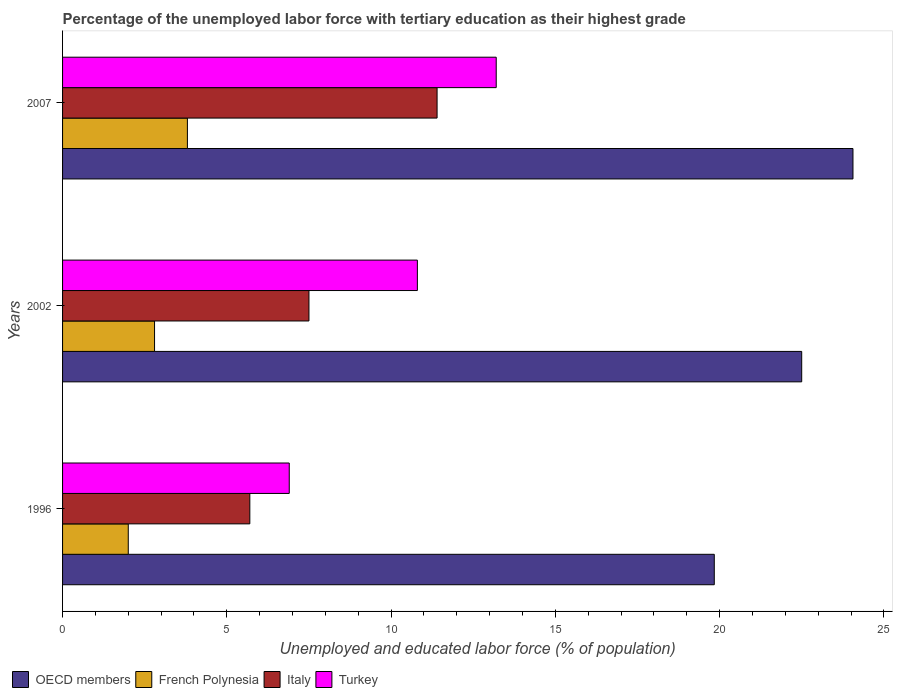How many different coloured bars are there?
Your response must be concise. 4. Are the number of bars per tick equal to the number of legend labels?
Offer a terse response. Yes. Are the number of bars on each tick of the Y-axis equal?
Ensure brevity in your answer.  Yes. How many bars are there on the 3rd tick from the top?
Ensure brevity in your answer.  4. What is the label of the 1st group of bars from the top?
Provide a succinct answer. 2007. In how many cases, is the number of bars for a given year not equal to the number of legend labels?
Offer a terse response. 0. What is the percentage of the unemployed labor force with tertiary education in Turkey in 2002?
Offer a terse response. 10.8. Across all years, what is the maximum percentage of the unemployed labor force with tertiary education in Turkey?
Your response must be concise. 13.2. Across all years, what is the minimum percentage of the unemployed labor force with tertiary education in Turkey?
Your answer should be compact. 6.9. What is the total percentage of the unemployed labor force with tertiary education in OECD members in the graph?
Provide a short and direct response. 66.4. What is the difference between the percentage of the unemployed labor force with tertiary education in Italy in 1996 and that in 2007?
Ensure brevity in your answer.  -5.7. What is the difference between the percentage of the unemployed labor force with tertiary education in Turkey in 1996 and the percentage of the unemployed labor force with tertiary education in French Polynesia in 2007?
Provide a succinct answer. 3.1. What is the average percentage of the unemployed labor force with tertiary education in Turkey per year?
Make the answer very short. 10.3. In the year 1996, what is the difference between the percentage of the unemployed labor force with tertiary education in Turkey and percentage of the unemployed labor force with tertiary education in OECD members?
Provide a short and direct response. -12.94. What is the ratio of the percentage of the unemployed labor force with tertiary education in Italy in 1996 to that in 2007?
Make the answer very short. 0.5. What is the difference between the highest and the second highest percentage of the unemployed labor force with tertiary education in Turkey?
Your answer should be very brief. 2.4. What is the difference between the highest and the lowest percentage of the unemployed labor force with tertiary education in French Polynesia?
Provide a short and direct response. 1.8. Is it the case that in every year, the sum of the percentage of the unemployed labor force with tertiary education in Turkey and percentage of the unemployed labor force with tertiary education in French Polynesia is greater than the sum of percentage of the unemployed labor force with tertiary education in OECD members and percentage of the unemployed labor force with tertiary education in Italy?
Give a very brief answer. No. What does the 3rd bar from the top in 1996 represents?
Your answer should be very brief. French Polynesia. What does the 1st bar from the bottom in 1996 represents?
Give a very brief answer. OECD members. How many bars are there?
Provide a short and direct response. 12. What is the difference between two consecutive major ticks on the X-axis?
Offer a very short reply. 5. Are the values on the major ticks of X-axis written in scientific E-notation?
Ensure brevity in your answer.  No. How are the legend labels stacked?
Offer a very short reply. Horizontal. What is the title of the graph?
Ensure brevity in your answer.  Percentage of the unemployed labor force with tertiary education as their highest grade. Does "Cameroon" appear as one of the legend labels in the graph?
Keep it short and to the point. No. What is the label or title of the X-axis?
Give a very brief answer. Unemployed and educated labor force (% of population). What is the Unemployed and educated labor force (% of population) in OECD members in 1996?
Your answer should be very brief. 19.84. What is the Unemployed and educated labor force (% of population) in French Polynesia in 1996?
Your answer should be very brief. 2. What is the Unemployed and educated labor force (% of population) in Italy in 1996?
Provide a succinct answer. 5.7. What is the Unemployed and educated labor force (% of population) of Turkey in 1996?
Keep it short and to the point. 6.9. What is the Unemployed and educated labor force (% of population) of OECD members in 2002?
Offer a terse response. 22.5. What is the Unemployed and educated labor force (% of population) of French Polynesia in 2002?
Give a very brief answer. 2.8. What is the Unemployed and educated labor force (% of population) in Italy in 2002?
Ensure brevity in your answer.  7.5. What is the Unemployed and educated labor force (% of population) of Turkey in 2002?
Your answer should be compact. 10.8. What is the Unemployed and educated labor force (% of population) of OECD members in 2007?
Offer a terse response. 24.06. What is the Unemployed and educated labor force (% of population) in French Polynesia in 2007?
Your answer should be compact. 3.8. What is the Unemployed and educated labor force (% of population) of Italy in 2007?
Offer a terse response. 11.4. What is the Unemployed and educated labor force (% of population) of Turkey in 2007?
Your answer should be very brief. 13.2. Across all years, what is the maximum Unemployed and educated labor force (% of population) of OECD members?
Provide a short and direct response. 24.06. Across all years, what is the maximum Unemployed and educated labor force (% of population) of French Polynesia?
Provide a short and direct response. 3.8. Across all years, what is the maximum Unemployed and educated labor force (% of population) of Italy?
Your answer should be compact. 11.4. Across all years, what is the maximum Unemployed and educated labor force (% of population) in Turkey?
Provide a short and direct response. 13.2. Across all years, what is the minimum Unemployed and educated labor force (% of population) in OECD members?
Your answer should be very brief. 19.84. Across all years, what is the minimum Unemployed and educated labor force (% of population) in Italy?
Your answer should be compact. 5.7. Across all years, what is the minimum Unemployed and educated labor force (% of population) of Turkey?
Keep it short and to the point. 6.9. What is the total Unemployed and educated labor force (% of population) in OECD members in the graph?
Make the answer very short. 66.4. What is the total Unemployed and educated labor force (% of population) of Italy in the graph?
Your answer should be very brief. 24.6. What is the total Unemployed and educated labor force (% of population) in Turkey in the graph?
Offer a very short reply. 30.9. What is the difference between the Unemployed and educated labor force (% of population) of OECD members in 1996 and that in 2002?
Your response must be concise. -2.66. What is the difference between the Unemployed and educated labor force (% of population) of French Polynesia in 1996 and that in 2002?
Offer a very short reply. -0.8. What is the difference between the Unemployed and educated labor force (% of population) of Italy in 1996 and that in 2002?
Your answer should be very brief. -1.8. What is the difference between the Unemployed and educated labor force (% of population) of OECD members in 1996 and that in 2007?
Offer a terse response. -4.22. What is the difference between the Unemployed and educated labor force (% of population) in Italy in 1996 and that in 2007?
Provide a succinct answer. -5.7. What is the difference between the Unemployed and educated labor force (% of population) of OECD members in 2002 and that in 2007?
Your answer should be very brief. -1.56. What is the difference between the Unemployed and educated labor force (% of population) in French Polynesia in 2002 and that in 2007?
Your answer should be compact. -1. What is the difference between the Unemployed and educated labor force (% of population) in OECD members in 1996 and the Unemployed and educated labor force (% of population) in French Polynesia in 2002?
Offer a terse response. 17.04. What is the difference between the Unemployed and educated labor force (% of population) of OECD members in 1996 and the Unemployed and educated labor force (% of population) of Italy in 2002?
Keep it short and to the point. 12.34. What is the difference between the Unemployed and educated labor force (% of population) of OECD members in 1996 and the Unemployed and educated labor force (% of population) of Turkey in 2002?
Offer a very short reply. 9.04. What is the difference between the Unemployed and educated labor force (% of population) of French Polynesia in 1996 and the Unemployed and educated labor force (% of population) of Turkey in 2002?
Make the answer very short. -8.8. What is the difference between the Unemployed and educated labor force (% of population) in OECD members in 1996 and the Unemployed and educated labor force (% of population) in French Polynesia in 2007?
Provide a succinct answer. 16.04. What is the difference between the Unemployed and educated labor force (% of population) of OECD members in 1996 and the Unemployed and educated labor force (% of population) of Italy in 2007?
Offer a very short reply. 8.44. What is the difference between the Unemployed and educated labor force (% of population) in OECD members in 1996 and the Unemployed and educated labor force (% of population) in Turkey in 2007?
Offer a very short reply. 6.64. What is the difference between the Unemployed and educated labor force (% of population) of French Polynesia in 1996 and the Unemployed and educated labor force (% of population) of Italy in 2007?
Your answer should be compact. -9.4. What is the difference between the Unemployed and educated labor force (% of population) of OECD members in 2002 and the Unemployed and educated labor force (% of population) of French Polynesia in 2007?
Offer a terse response. 18.7. What is the difference between the Unemployed and educated labor force (% of population) of OECD members in 2002 and the Unemployed and educated labor force (% of population) of Italy in 2007?
Provide a succinct answer. 11.1. What is the difference between the Unemployed and educated labor force (% of population) in OECD members in 2002 and the Unemployed and educated labor force (% of population) in Turkey in 2007?
Ensure brevity in your answer.  9.3. What is the difference between the Unemployed and educated labor force (% of population) of French Polynesia in 2002 and the Unemployed and educated labor force (% of population) of Italy in 2007?
Provide a succinct answer. -8.6. What is the difference between the Unemployed and educated labor force (% of population) in French Polynesia in 2002 and the Unemployed and educated labor force (% of population) in Turkey in 2007?
Your answer should be very brief. -10.4. What is the difference between the Unemployed and educated labor force (% of population) in Italy in 2002 and the Unemployed and educated labor force (% of population) in Turkey in 2007?
Offer a very short reply. -5.7. What is the average Unemployed and educated labor force (% of population) in OECD members per year?
Your answer should be compact. 22.13. What is the average Unemployed and educated labor force (% of population) in French Polynesia per year?
Provide a short and direct response. 2.87. What is the average Unemployed and educated labor force (% of population) of Italy per year?
Provide a succinct answer. 8.2. What is the average Unemployed and educated labor force (% of population) of Turkey per year?
Your response must be concise. 10.3. In the year 1996, what is the difference between the Unemployed and educated labor force (% of population) in OECD members and Unemployed and educated labor force (% of population) in French Polynesia?
Ensure brevity in your answer.  17.84. In the year 1996, what is the difference between the Unemployed and educated labor force (% of population) in OECD members and Unemployed and educated labor force (% of population) in Italy?
Your answer should be compact. 14.14. In the year 1996, what is the difference between the Unemployed and educated labor force (% of population) of OECD members and Unemployed and educated labor force (% of population) of Turkey?
Keep it short and to the point. 12.94. In the year 1996, what is the difference between the Unemployed and educated labor force (% of population) in French Polynesia and Unemployed and educated labor force (% of population) in Italy?
Offer a very short reply. -3.7. In the year 2002, what is the difference between the Unemployed and educated labor force (% of population) in OECD members and Unemployed and educated labor force (% of population) in French Polynesia?
Give a very brief answer. 19.7. In the year 2002, what is the difference between the Unemployed and educated labor force (% of population) of OECD members and Unemployed and educated labor force (% of population) of Italy?
Provide a short and direct response. 15. In the year 2002, what is the difference between the Unemployed and educated labor force (% of population) in OECD members and Unemployed and educated labor force (% of population) in Turkey?
Offer a very short reply. 11.7. In the year 2002, what is the difference between the Unemployed and educated labor force (% of population) of Italy and Unemployed and educated labor force (% of population) of Turkey?
Offer a terse response. -3.3. In the year 2007, what is the difference between the Unemployed and educated labor force (% of population) in OECD members and Unemployed and educated labor force (% of population) in French Polynesia?
Offer a terse response. 20.26. In the year 2007, what is the difference between the Unemployed and educated labor force (% of population) in OECD members and Unemployed and educated labor force (% of population) in Italy?
Make the answer very short. 12.66. In the year 2007, what is the difference between the Unemployed and educated labor force (% of population) in OECD members and Unemployed and educated labor force (% of population) in Turkey?
Your answer should be very brief. 10.86. In the year 2007, what is the difference between the Unemployed and educated labor force (% of population) in French Polynesia and Unemployed and educated labor force (% of population) in Italy?
Keep it short and to the point. -7.6. In the year 2007, what is the difference between the Unemployed and educated labor force (% of population) in French Polynesia and Unemployed and educated labor force (% of population) in Turkey?
Your response must be concise. -9.4. What is the ratio of the Unemployed and educated labor force (% of population) of OECD members in 1996 to that in 2002?
Provide a succinct answer. 0.88. What is the ratio of the Unemployed and educated labor force (% of population) of French Polynesia in 1996 to that in 2002?
Keep it short and to the point. 0.71. What is the ratio of the Unemployed and educated labor force (% of population) of Italy in 1996 to that in 2002?
Your response must be concise. 0.76. What is the ratio of the Unemployed and educated labor force (% of population) in Turkey in 1996 to that in 2002?
Your response must be concise. 0.64. What is the ratio of the Unemployed and educated labor force (% of population) of OECD members in 1996 to that in 2007?
Keep it short and to the point. 0.82. What is the ratio of the Unemployed and educated labor force (% of population) of French Polynesia in 1996 to that in 2007?
Make the answer very short. 0.53. What is the ratio of the Unemployed and educated labor force (% of population) in Italy in 1996 to that in 2007?
Your answer should be very brief. 0.5. What is the ratio of the Unemployed and educated labor force (% of population) of Turkey in 1996 to that in 2007?
Offer a terse response. 0.52. What is the ratio of the Unemployed and educated labor force (% of population) of OECD members in 2002 to that in 2007?
Ensure brevity in your answer.  0.94. What is the ratio of the Unemployed and educated labor force (% of population) in French Polynesia in 2002 to that in 2007?
Provide a short and direct response. 0.74. What is the ratio of the Unemployed and educated labor force (% of population) in Italy in 2002 to that in 2007?
Provide a succinct answer. 0.66. What is the ratio of the Unemployed and educated labor force (% of population) of Turkey in 2002 to that in 2007?
Give a very brief answer. 0.82. What is the difference between the highest and the second highest Unemployed and educated labor force (% of population) of OECD members?
Keep it short and to the point. 1.56. What is the difference between the highest and the second highest Unemployed and educated labor force (% of population) of Italy?
Provide a short and direct response. 3.9. What is the difference between the highest and the lowest Unemployed and educated labor force (% of population) of OECD members?
Make the answer very short. 4.22. What is the difference between the highest and the lowest Unemployed and educated labor force (% of population) of French Polynesia?
Your answer should be very brief. 1.8. What is the difference between the highest and the lowest Unemployed and educated labor force (% of population) in Italy?
Ensure brevity in your answer.  5.7. What is the difference between the highest and the lowest Unemployed and educated labor force (% of population) of Turkey?
Ensure brevity in your answer.  6.3. 